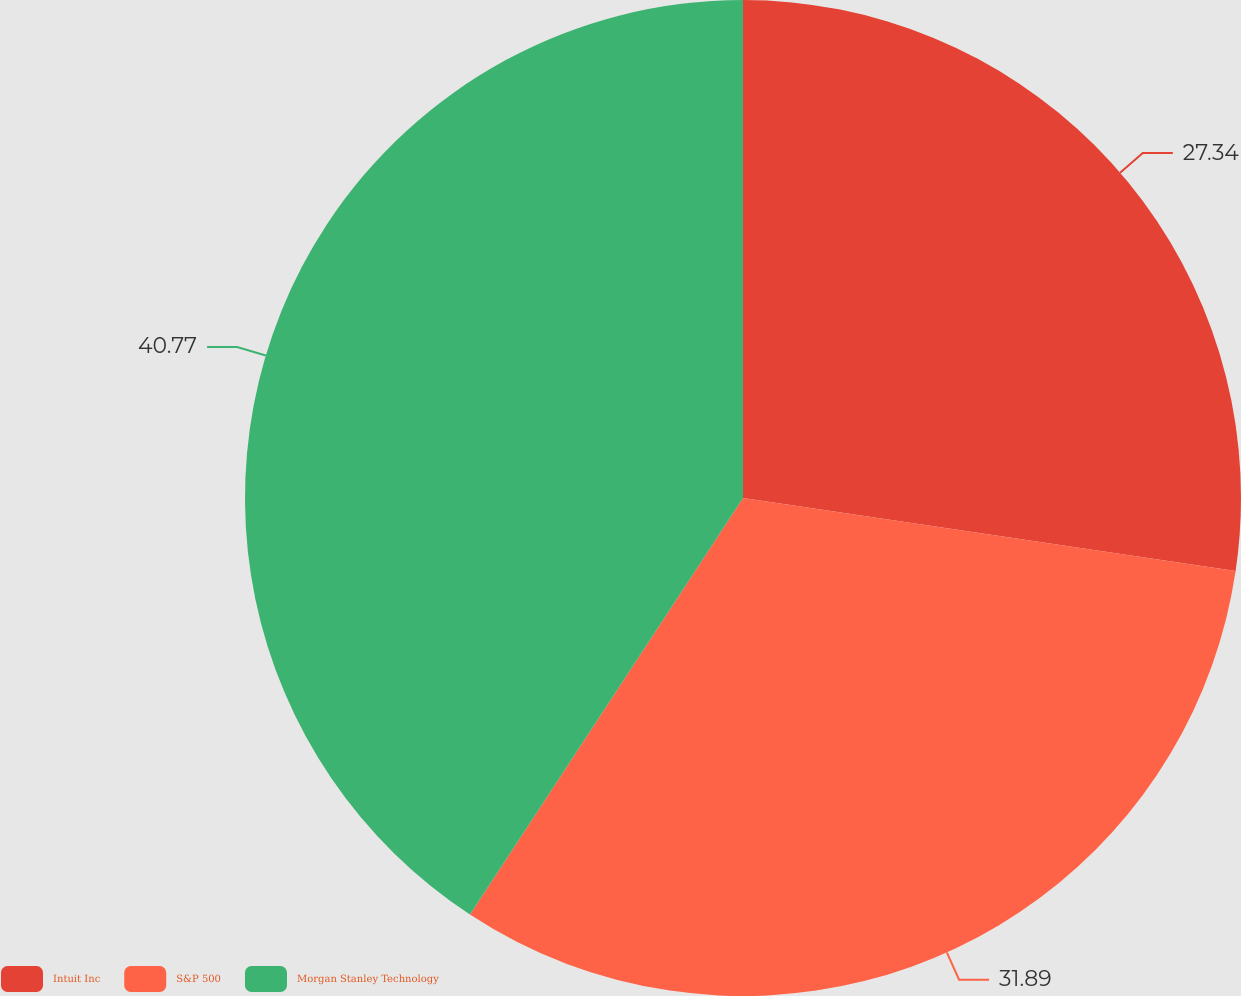<chart> <loc_0><loc_0><loc_500><loc_500><pie_chart><fcel>Intuit Inc<fcel>S&P 500<fcel>Morgan Stanley Technology<nl><fcel>27.34%<fcel>31.89%<fcel>40.76%<nl></chart> 